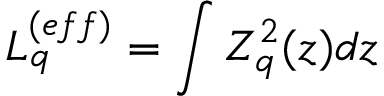<formula> <loc_0><loc_0><loc_500><loc_500>L _ { q } ^ { ( e f f ) } = \int Z _ { q } ^ { 2 } ( z ) d z</formula> 